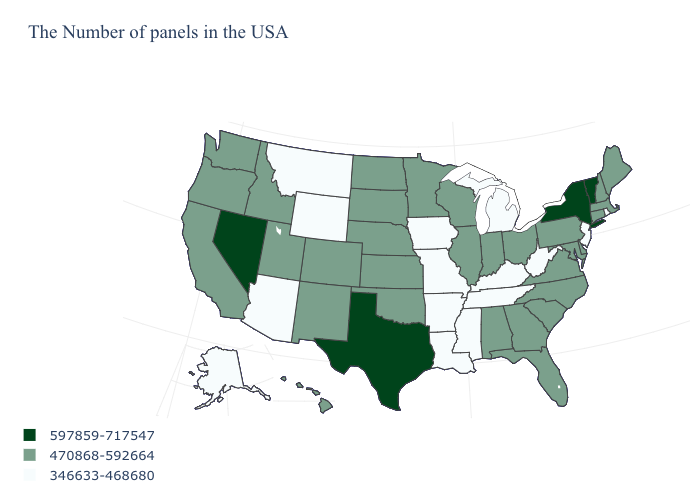Which states have the lowest value in the USA?
Keep it brief. Rhode Island, New Jersey, West Virginia, Michigan, Kentucky, Tennessee, Mississippi, Louisiana, Missouri, Arkansas, Iowa, Wyoming, Montana, Arizona, Alaska. What is the lowest value in the USA?
Be succinct. 346633-468680. Name the states that have a value in the range 346633-468680?
Write a very short answer. Rhode Island, New Jersey, West Virginia, Michigan, Kentucky, Tennessee, Mississippi, Louisiana, Missouri, Arkansas, Iowa, Wyoming, Montana, Arizona, Alaska. Does Maine have a higher value than North Carolina?
Concise answer only. No. Name the states that have a value in the range 470868-592664?
Concise answer only. Maine, Massachusetts, New Hampshire, Connecticut, Delaware, Maryland, Pennsylvania, Virginia, North Carolina, South Carolina, Ohio, Florida, Georgia, Indiana, Alabama, Wisconsin, Illinois, Minnesota, Kansas, Nebraska, Oklahoma, South Dakota, North Dakota, Colorado, New Mexico, Utah, Idaho, California, Washington, Oregon, Hawaii. Among the states that border Wyoming , does Nebraska have the lowest value?
Short answer required. No. Does New Jersey have the lowest value in the USA?
Keep it brief. Yes. What is the value of Alaska?
Keep it brief. 346633-468680. What is the value of Texas?
Short answer required. 597859-717547. Among the states that border Oklahoma , which have the lowest value?
Answer briefly. Missouri, Arkansas. Does the map have missing data?
Quick response, please. No. What is the value of Michigan?
Write a very short answer. 346633-468680. Does Nevada have the highest value in the USA?
Give a very brief answer. Yes. What is the highest value in the USA?
Be succinct. 597859-717547. Among the states that border Delaware , does Pennsylvania have the lowest value?
Short answer required. No. 